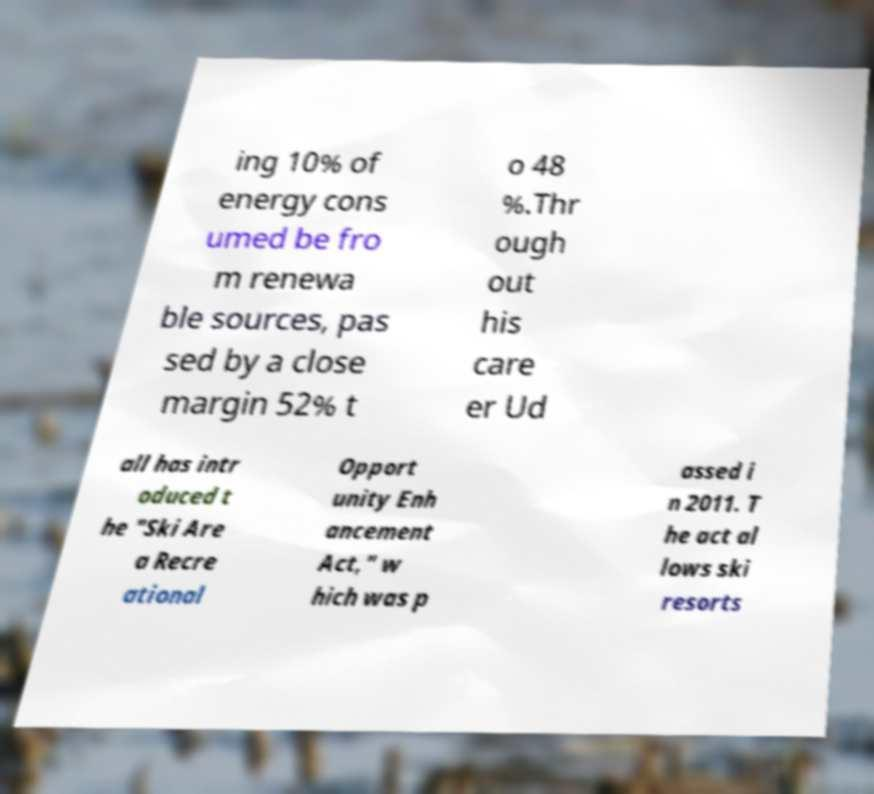Can you accurately transcribe the text from the provided image for me? ing 10% of energy cons umed be fro m renewa ble sources, pas sed by a close margin 52% t o 48 %.Thr ough out his care er Ud all has intr oduced t he "Ski Are a Recre ational Opport unity Enh ancement Act," w hich was p assed i n 2011. T he act al lows ski resorts 